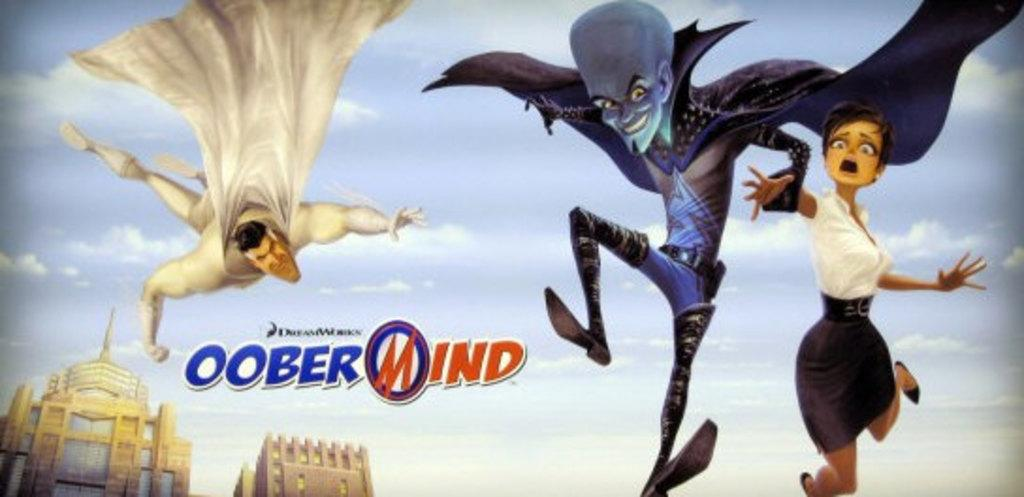<image>
Relay a brief, clear account of the picture shown. a poster for a movie that is called oober wind 